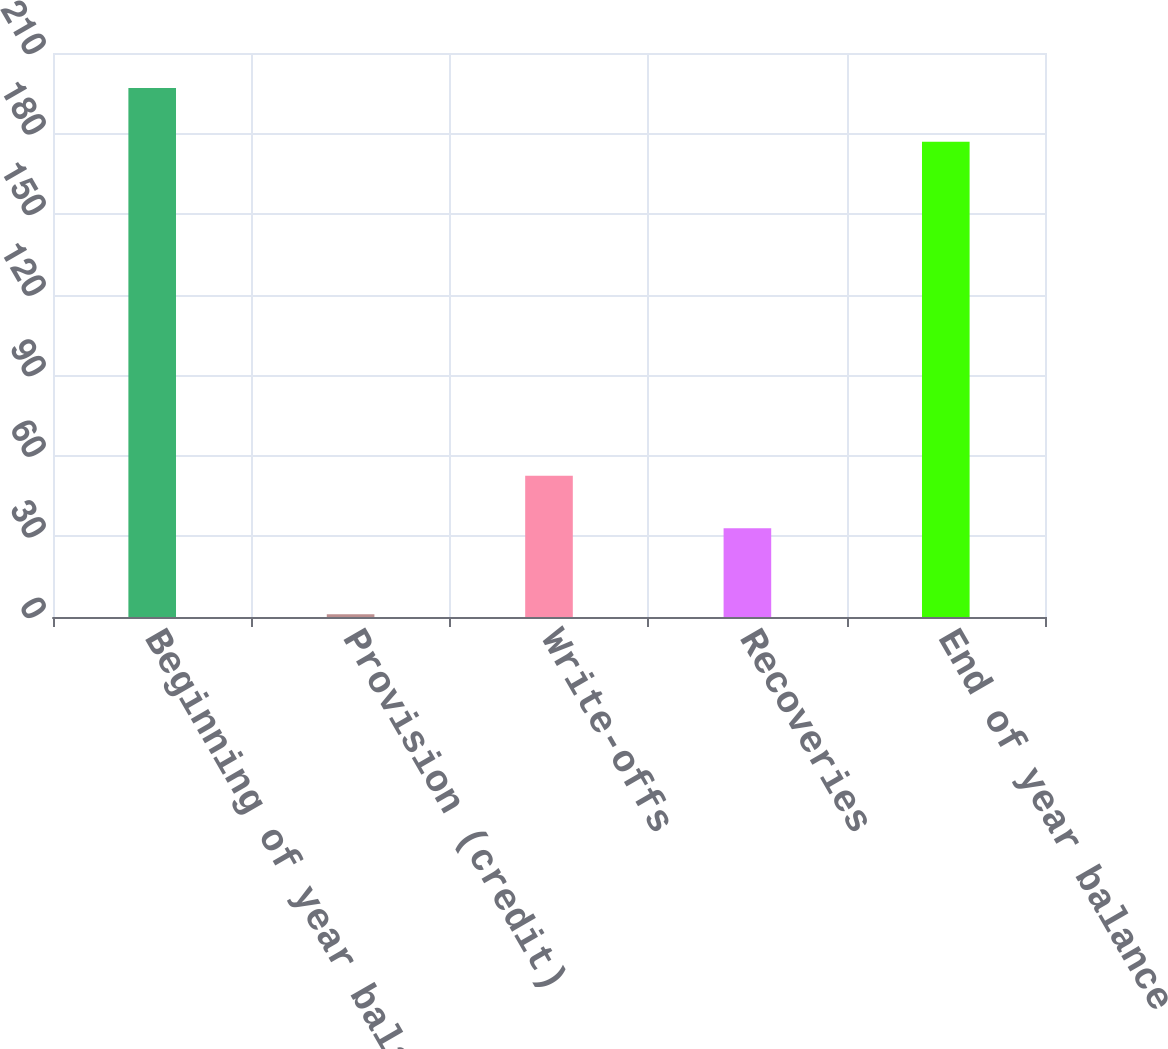Convert chart. <chart><loc_0><loc_0><loc_500><loc_500><bar_chart><fcel>Beginning of year balance<fcel>Provision (credit)<fcel>Write-offs<fcel>Recoveries<fcel>End of year balance<nl><fcel>197<fcel>1<fcel>52.6<fcel>33<fcel>177<nl></chart> 